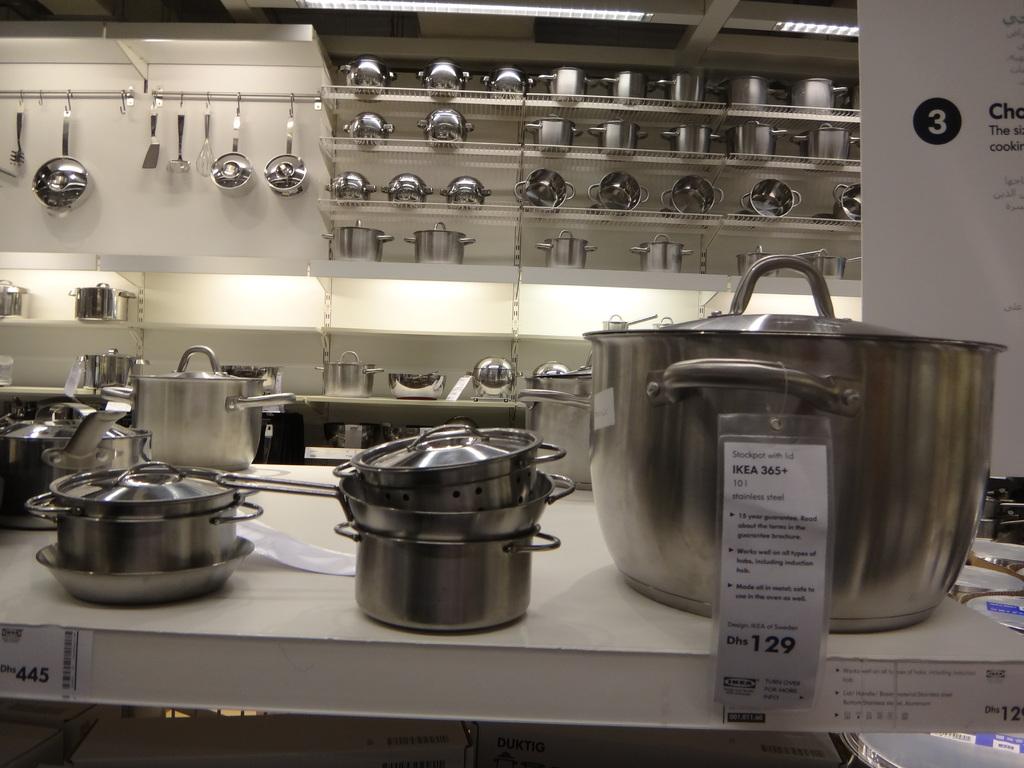How much is the largest pot?
Your answer should be compact. 129. What number is in the black circle?
Ensure brevity in your answer.  3. 